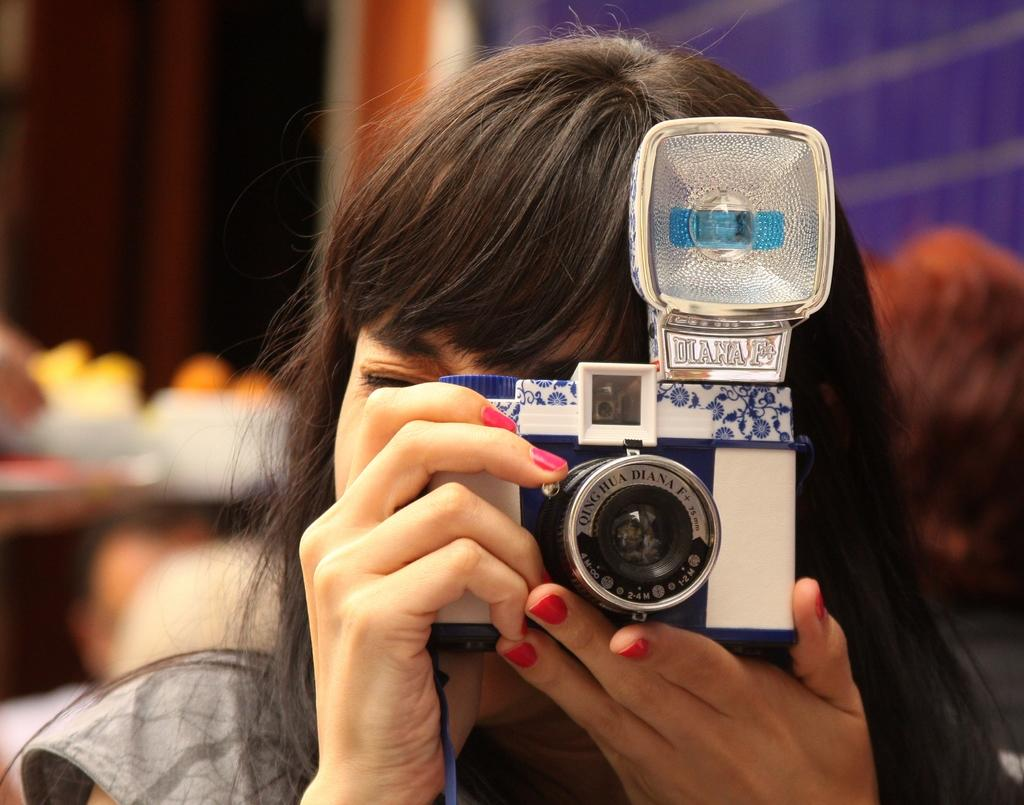Who is the main subject in the image? There is a woman in the image. What is the woman doing in the image? The woman is standing and holding a camera in her hand. Can you describe the background of the image? The background of the image is blurry. What type of verse is the woman reciting in the image? There is no verse or any indication of the woman reciting anything in the image. 